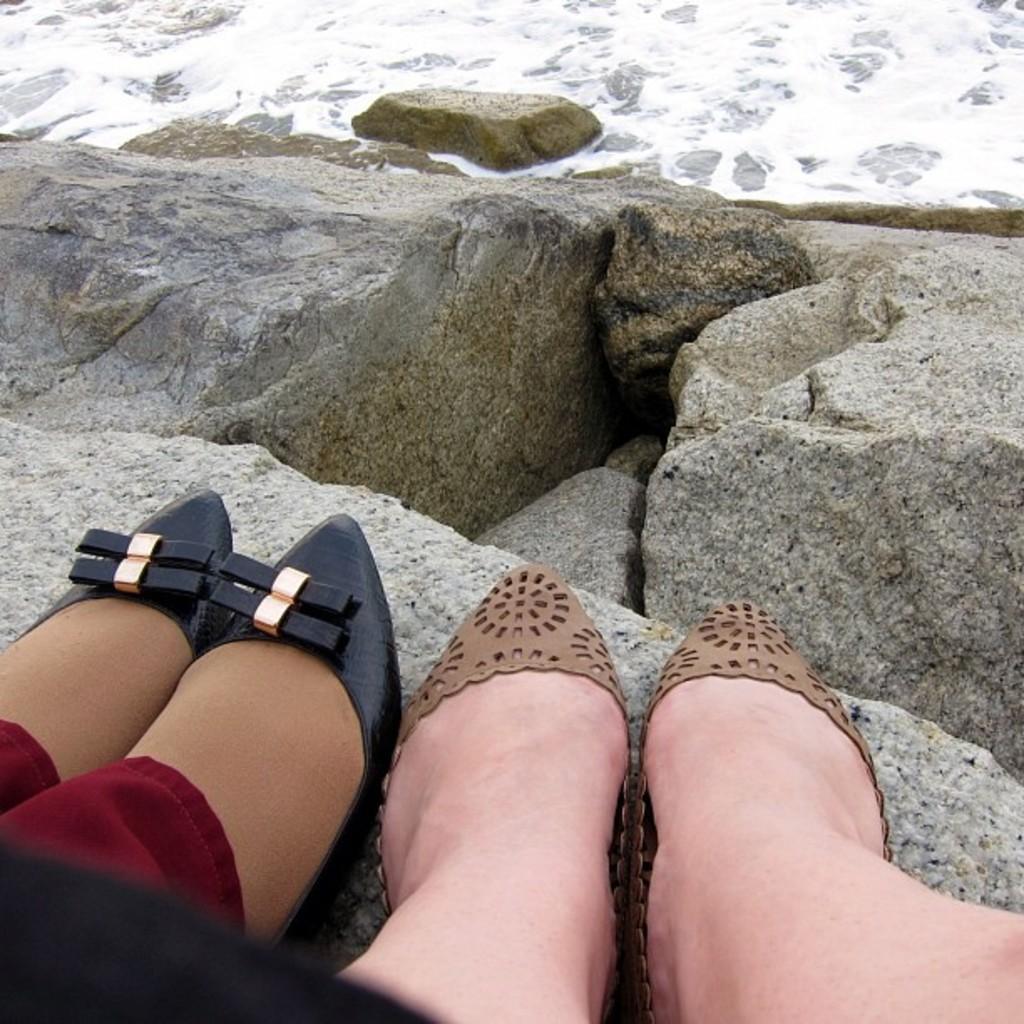Could you give a brief overview of what you see in this image? In this image, we can see the legs of a few people. We can see some stones and water. 